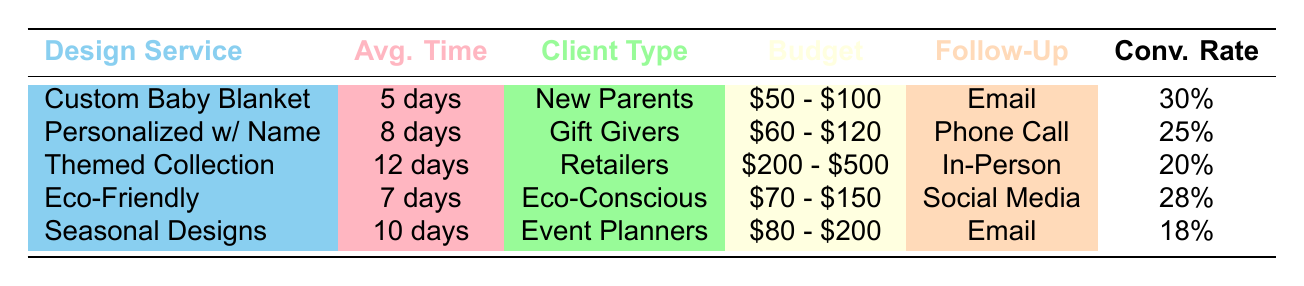What's the average time to conversion for Custom Baby Blanket Design? From the table, the average time to conversion for Custom Baby Blanket Design is specifically listed as 5 days under the "Avg. Time" column.
Answer: 5 days What is the typical budget for Themed Baby Blanket Collection? The typical budget for Themed Baby Blanket Collection is provided directly in the table, noted as $200 - $500 under the "Budget" column.
Answer: $200 - $500 Which design service has the highest conversion rate and what is that rate? By looking at the "Conv. Rate" column, Custom Baby Blanket Design has the highest conversion rate at 30%.
Answer: 30% Is the Average Time to Conversion longer for Personalized Baby Blanket with Name compared to Eco-Friendly Baby Blankets? The average time for Personalized Baby Blanket with Name is 8 days, while for Eco-Friendly Baby Blankets, it is 7 days. Since 8 is greater than 7, the statement is true.
Answer: Yes What are the conversion rates for services with an average time to conversion of 10 days or longer? The services with an average time to conversion of 10 days or longer are Themed Baby Blanket Collection (12 days, 20% conversion rate) and Seasonal Baby Blanket Designs (10 days, 18% conversion rate). Therefore, we have conversion rates of 20% and 18%.
Answer: 20%, 18% What is the average budget range of all the design services in the table? To calculate the average budget, first identify the ranges: $50 - $100, $60 - $120, $200 - $500, $70 - $150, and $80 - $200. The average can be approximated by analyzing midpoints: ($75 + $90 + $350 + $110 + $140) / 5 = $193. The average budget is approximately $193.
Answer: $193 Is the average time to conversion for Event Planners longer than for Gift Givers? The average time to conversion for Event Planners (10 days) is longer than that for Gift Givers (8 days). Therefore, the statement is true.
Answer: Yes How many design services have a conversion rate of 25% or higher? By reviewing the "Conv. Rate" column, Custom Baby Blanket Design (30%), Eco-Friendly Baby Blankets (28%), and Personalized Baby Blanket with Name (25%) all meet or exceed the 25% mark, totaling three design services.
Answer: 3 What is the follow-up method for the service with the lowest conversion rate? The service with the lowest conversion rate is Seasonal Baby Blanket Designs, which has a conversion rate of 18% and its follow-up method is listed as Email.
Answer: Email 